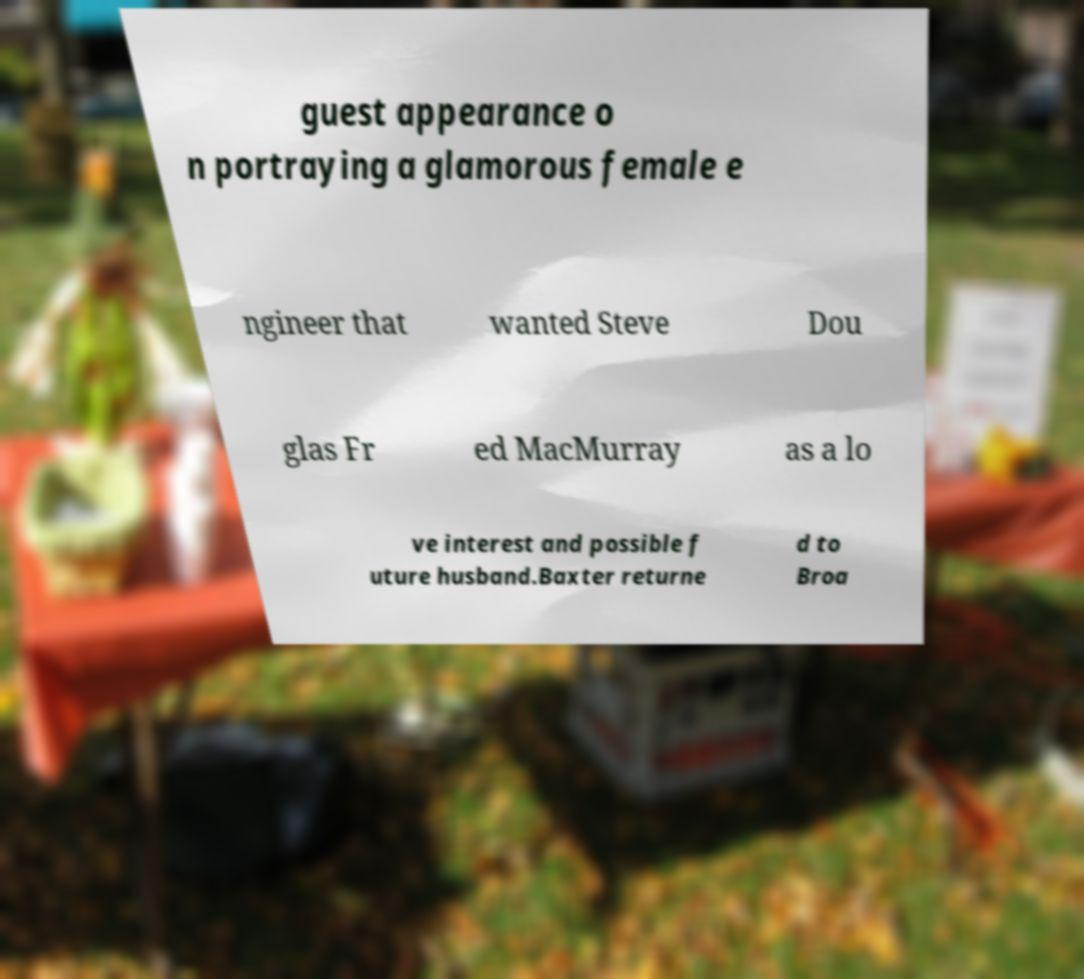Can you read and provide the text displayed in the image?This photo seems to have some interesting text. Can you extract and type it out for me? guest appearance o n portraying a glamorous female e ngineer that wanted Steve Dou glas Fr ed MacMurray as a lo ve interest and possible f uture husband.Baxter returne d to Broa 